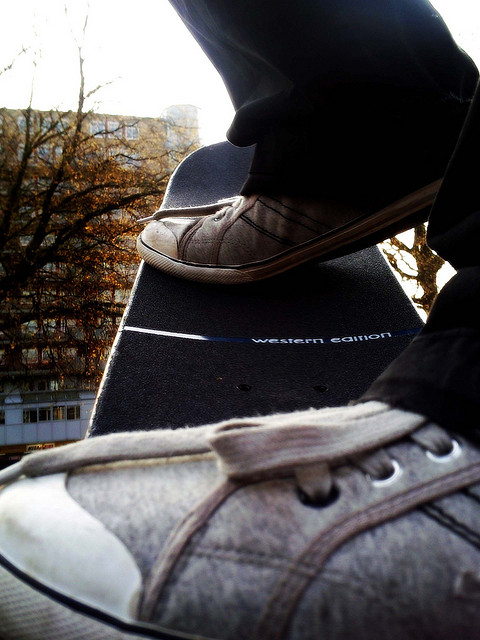<image>What method of mass transit is shown? I don't know what method of mass transit is shown. It can be either a skateboard or a train. What method of mass transit is shown? I don't know the method of mass transit shown. It can be either a skateboard or a train. 